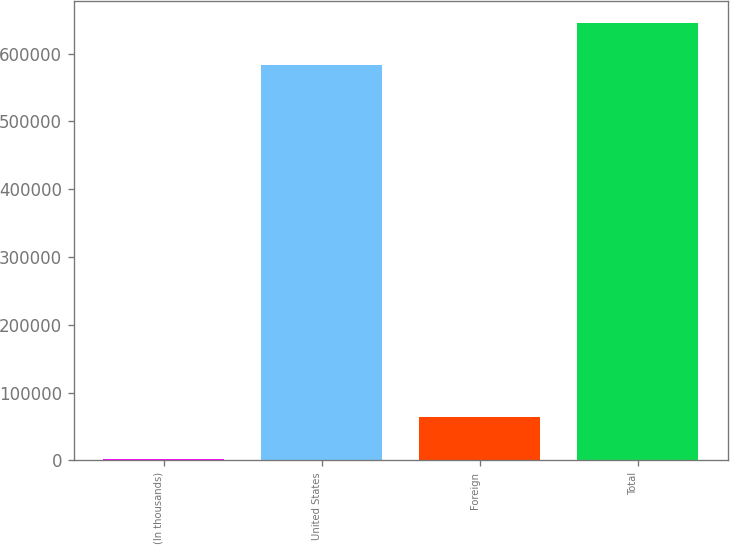Convert chart. <chart><loc_0><loc_0><loc_500><loc_500><bar_chart><fcel>(In thousands)<fcel>United States<fcel>Foreign<fcel>Total<nl><fcel>2006<fcel>583676<fcel>63430<fcel>645100<nl></chart> 